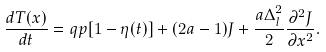Convert formula to latex. <formula><loc_0><loc_0><loc_500><loc_500>\frac { d T ( x ) } { d t } = q p [ 1 - \eta ( t ) ] + ( 2 a - 1 ) J + \frac { a \Delta _ { l } ^ { 2 } } { 2 } \frac { \partial ^ { 2 } J } { \partial x ^ { 2 } } .</formula> 